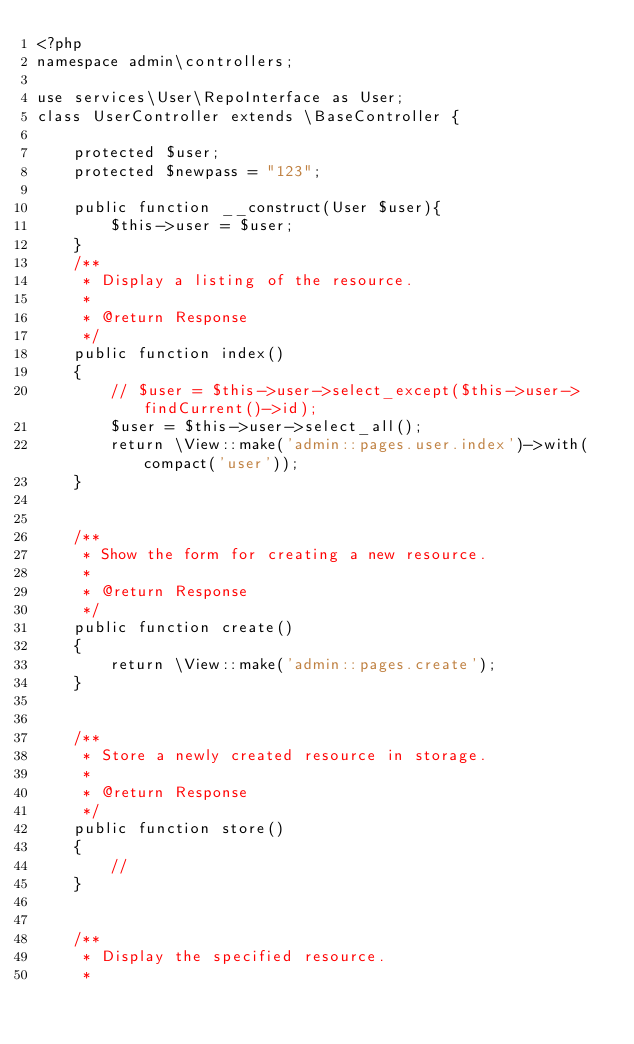Convert code to text. <code><loc_0><loc_0><loc_500><loc_500><_PHP_><?php
namespace admin\controllers;

use services\User\RepoInterface as User;
class UserController extends \BaseController {

	protected $user;
	protected $newpass = "123";

	public function __construct(User $user){
		$this->user = $user;
	}
	/**
	 * Display a listing of the resource.
	 *
	 * @return Response
	 */
	public function index()
	{
		// $user = $this->user->select_except($this->user->findCurrent()->id);
		$user = $this->user->select_all();
		return \View::make('admin::pages.user.index')->with(compact('user'));
	}


	/**
	 * Show the form for creating a new resource.
	 *
	 * @return Response
	 */
	public function create()
	{
		return \View::make('admin::pages.create');
	}


	/**
	 * Store a newly created resource in storage.
	 *
	 * @return Response
	 */
	public function store()
	{
		//
	}


	/**
	 * Display the specified resource.
	 *</code> 